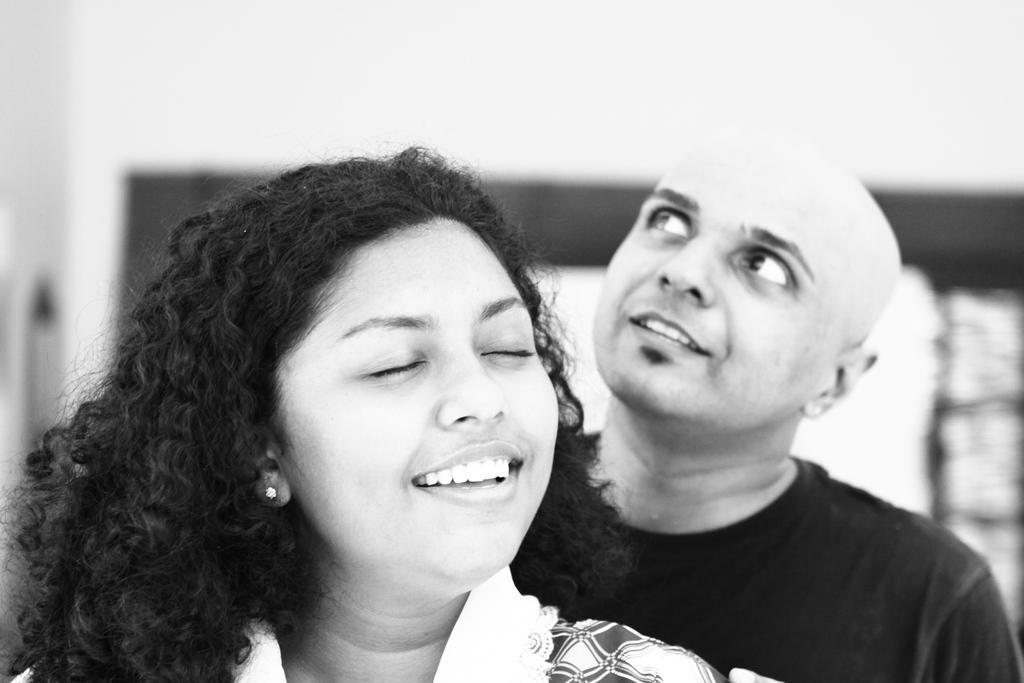Could you give a brief overview of what you see in this image? This is a black and white picture. In this image we can see a woman and behind her there is a man. In the background the image is blur but we can wall and objects. 